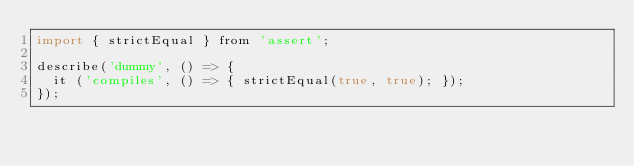<code> <loc_0><loc_0><loc_500><loc_500><_JavaScript_>import { strictEqual } from 'assert';

describe('dummy', () => {
  it ('compiles', () => { strictEqual(true, true); });
});
</code> 